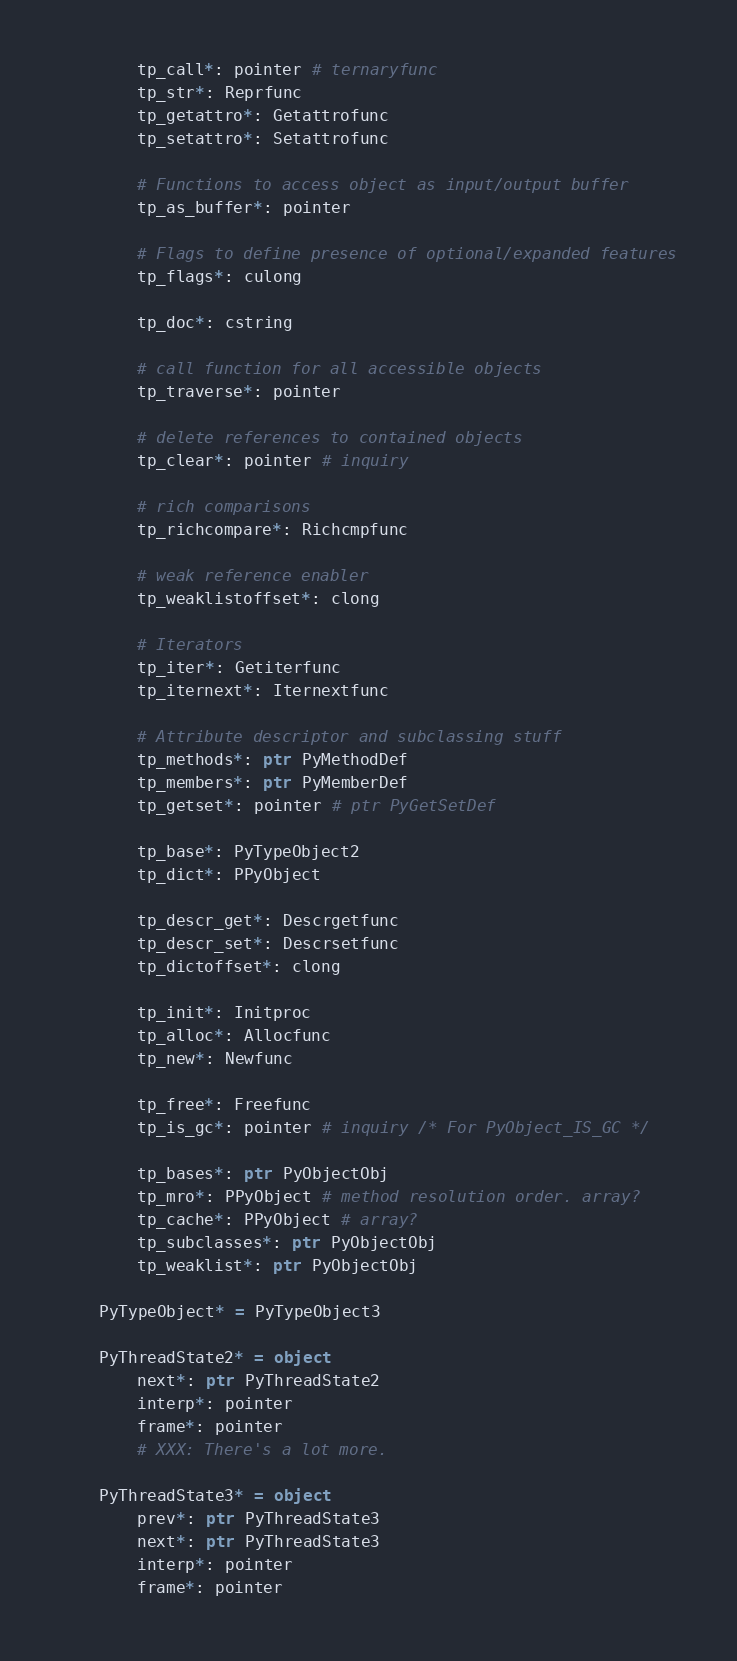Convert code to text. <code><loc_0><loc_0><loc_500><loc_500><_Nim_>        tp_call*: pointer # ternaryfunc
        tp_str*: Reprfunc
        tp_getattro*: Getattrofunc
        tp_setattro*: Setattrofunc

        # Functions to access object as input/output buffer
        tp_as_buffer*: pointer

        # Flags to define presence of optional/expanded features
        tp_flags*: culong

        tp_doc*: cstring

        # call function for all accessible objects
        tp_traverse*: pointer

        # delete references to contained objects
        tp_clear*: pointer # inquiry

        # rich comparisons
        tp_richcompare*: Richcmpfunc

        # weak reference enabler
        tp_weaklistoffset*: clong

        # Iterators
        tp_iter*: Getiterfunc
        tp_iternext*: Iternextfunc

        # Attribute descriptor and subclassing stuff
        tp_methods*: ptr PyMethodDef
        tp_members*: ptr PyMemberDef
        tp_getset*: pointer # ptr PyGetSetDef

        tp_base*: PyTypeObject2
        tp_dict*: PPyObject

        tp_descr_get*: Descrgetfunc
        tp_descr_set*: Descrsetfunc
        tp_dictoffset*: clong

        tp_init*: Initproc
        tp_alloc*: Allocfunc
        tp_new*: Newfunc

        tp_free*: Freefunc
        tp_is_gc*: pointer # inquiry /* For PyObject_IS_GC */

        tp_bases*: ptr PyObjectObj
        tp_mro*: PPyObject # method resolution order. array?
        tp_cache*: PPyObject # array?
        tp_subclasses*: ptr PyObjectObj
        tp_weaklist*: ptr PyObjectObj

    PyTypeObject* = PyTypeObject3

    PyThreadState2* = object
        next*: ptr PyThreadState2
        interp*: pointer
        frame*: pointer
        # XXX: There's a lot more.

    PyThreadState3* = object
        prev*: ptr PyThreadState3
        next*: ptr PyThreadState3
        interp*: pointer
        frame*: pointer</code> 